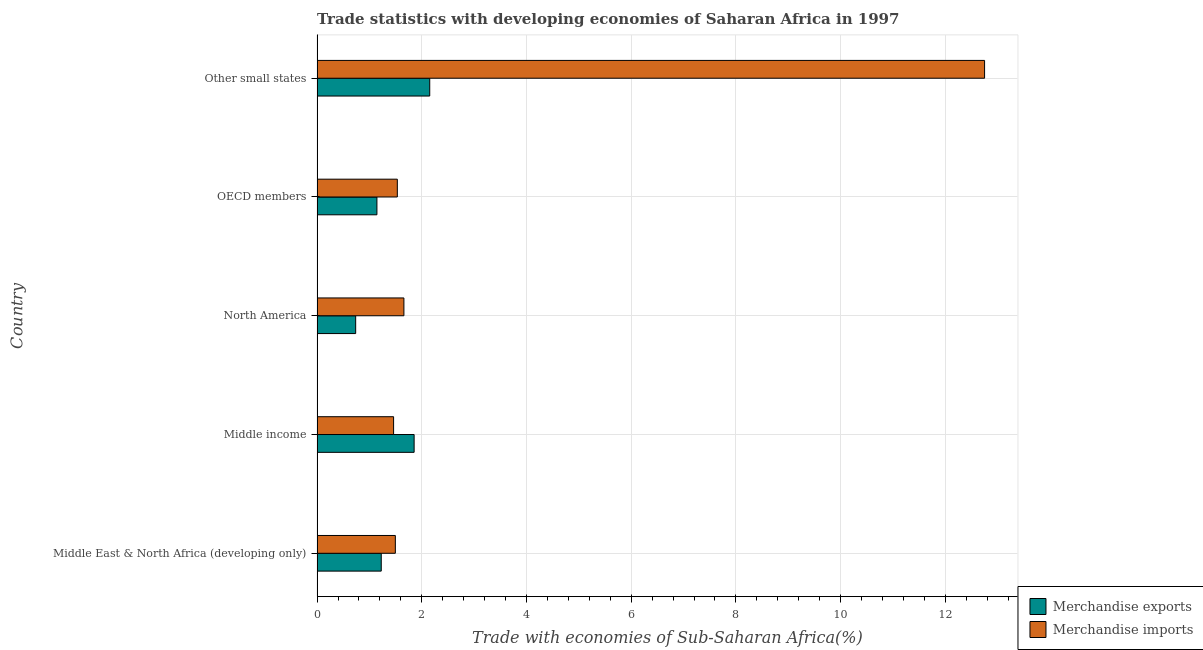How many different coloured bars are there?
Provide a short and direct response. 2. Are the number of bars per tick equal to the number of legend labels?
Your answer should be compact. Yes. Are the number of bars on each tick of the Y-axis equal?
Offer a terse response. Yes. What is the label of the 1st group of bars from the top?
Your answer should be compact. Other small states. What is the merchandise imports in North America?
Keep it short and to the point. 1.66. Across all countries, what is the maximum merchandise imports?
Your answer should be very brief. 12.75. Across all countries, what is the minimum merchandise imports?
Provide a succinct answer. 1.46. In which country was the merchandise imports maximum?
Make the answer very short. Other small states. What is the total merchandise imports in the graph?
Offer a very short reply. 18.9. What is the difference between the merchandise imports in North America and that in OECD members?
Give a very brief answer. 0.13. What is the difference between the merchandise exports in North America and the merchandise imports in Middle East & North Africa (developing only)?
Your response must be concise. -0.76. What is the average merchandise imports per country?
Offer a very short reply. 3.78. What is the difference between the merchandise exports and merchandise imports in OECD members?
Provide a short and direct response. -0.39. In how many countries, is the merchandise imports greater than 8 %?
Provide a succinct answer. 1. What is the ratio of the merchandise exports in Middle income to that in Other small states?
Your answer should be compact. 0.86. Is the merchandise exports in Middle income less than that in Other small states?
Offer a terse response. Yes. Is the difference between the merchandise exports in OECD members and Other small states greater than the difference between the merchandise imports in OECD members and Other small states?
Offer a very short reply. Yes. What is the difference between the highest and the second highest merchandise imports?
Offer a very short reply. 11.09. What is the difference between the highest and the lowest merchandise imports?
Ensure brevity in your answer.  11.29. In how many countries, is the merchandise exports greater than the average merchandise exports taken over all countries?
Your response must be concise. 2. What does the 2nd bar from the bottom in OECD members represents?
Give a very brief answer. Merchandise imports. How many bars are there?
Provide a succinct answer. 10. Are all the bars in the graph horizontal?
Provide a short and direct response. Yes. What is the difference between two consecutive major ticks on the X-axis?
Your response must be concise. 2. Does the graph contain grids?
Provide a succinct answer. Yes. Where does the legend appear in the graph?
Your response must be concise. Bottom right. How many legend labels are there?
Provide a succinct answer. 2. How are the legend labels stacked?
Your response must be concise. Vertical. What is the title of the graph?
Keep it short and to the point. Trade statistics with developing economies of Saharan Africa in 1997. What is the label or title of the X-axis?
Your answer should be compact. Trade with economies of Sub-Saharan Africa(%). What is the label or title of the Y-axis?
Offer a very short reply. Country. What is the Trade with economies of Sub-Saharan Africa(%) in Merchandise exports in Middle East & North Africa (developing only)?
Ensure brevity in your answer.  1.23. What is the Trade with economies of Sub-Saharan Africa(%) in Merchandise imports in Middle East & North Africa (developing only)?
Offer a terse response. 1.5. What is the Trade with economies of Sub-Saharan Africa(%) in Merchandise exports in Middle income?
Ensure brevity in your answer.  1.85. What is the Trade with economies of Sub-Saharan Africa(%) of Merchandise imports in Middle income?
Your answer should be very brief. 1.46. What is the Trade with economies of Sub-Saharan Africa(%) in Merchandise exports in North America?
Provide a short and direct response. 0.74. What is the Trade with economies of Sub-Saharan Africa(%) of Merchandise imports in North America?
Make the answer very short. 1.66. What is the Trade with economies of Sub-Saharan Africa(%) in Merchandise exports in OECD members?
Your answer should be very brief. 1.14. What is the Trade with economies of Sub-Saharan Africa(%) in Merchandise imports in OECD members?
Keep it short and to the point. 1.53. What is the Trade with economies of Sub-Saharan Africa(%) of Merchandise exports in Other small states?
Provide a short and direct response. 2.15. What is the Trade with economies of Sub-Saharan Africa(%) of Merchandise imports in Other small states?
Provide a short and direct response. 12.75. Across all countries, what is the maximum Trade with economies of Sub-Saharan Africa(%) in Merchandise exports?
Provide a short and direct response. 2.15. Across all countries, what is the maximum Trade with economies of Sub-Saharan Africa(%) in Merchandise imports?
Ensure brevity in your answer.  12.75. Across all countries, what is the minimum Trade with economies of Sub-Saharan Africa(%) in Merchandise exports?
Provide a succinct answer. 0.74. Across all countries, what is the minimum Trade with economies of Sub-Saharan Africa(%) in Merchandise imports?
Make the answer very short. 1.46. What is the total Trade with economies of Sub-Saharan Africa(%) in Merchandise exports in the graph?
Provide a short and direct response. 7.11. What is the total Trade with economies of Sub-Saharan Africa(%) of Merchandise imports in the graph?
Offer a terse response. 18.9. What is the difference between the Trade with economies of Sub-Saharan Africa(%) of Merchandise exports in Middle East & North Africa (developing only) and that in Middle income?
Provide a short and direct response. -0.63. What is the difference between the Trade with economies of Sub-Saharan Africa(%) of Merchandise imports in Middle East & North Africa (developing only) and that in Middle income?
Your answer should be compact. 0.03. What is the difference between the Trade with economies of Sub-Saharan Africa(%) in Merchandise exports in Middle East & North Africa (developing only) and that in North America?
Provide a succinct answer. 0.49. What is the difference between the Trade with economies of Sub-Saharan Africa(%) of Merchandise imports in Middle East & North Africa (developing only) and that in North America?
Keep it short and to the point. -0.16. What is the difference between the Trade with economies of Sub-Saharan Africa(%) in Merchandise exports in Middle East & North Africa (developing only) and that in OECD members?
Offer a very short reply. 0.08. What is the difference between the Trade with economies of Sub-Saharan Africa(%) of Merchandise imports in Middle East & North Africa (developing only) and that in OECD members?
Offer a very short reply. -0.04. What is the difference between the Trade with economies of Sub-Saharan Africa(%) of Merchandise exports in Middle East & North Africa (developing only) and that in Other small states?
Your answer should be very brief. -0.93. What is the difference between the Trade with economies of Sub-Saharan Africa(%) of Merchandise imports in Middle East & North Africa (developing only) and that in Other small states?
Give a very brief answer. -11.25. What is the difference between the Trade with economies of Sub-Saharan Africa(%) of Merchandise exports in Middle income and that in North America?
Your answer should be very brief. 1.12. What is the difference between the Trade with economies of Sub-Saharan Africa(%) of Merchandise imports in Middle income and that in North America?
Offer a terse response. -0.2. What is the difference between the Trade with economies of Sub-Saharan Africa(%) of Merchandise exports in Middle income and that in OECD members?
Make the answer very short. 0.71. What is the difference between the Trade with economies of Sub-Saharan Africa(%) in Merchandise imports in Middle income and that in OECD members?
Give a very brief answer. -0.07. What is the difference between the Trade with economies of Sub-Saharan Africa(%) of Merchandise exports in Middle income and that in Other small states?
Your response must be concise. -0.3. What is the difference between the Trade with economies of Sub-Saharan Africa(%) of Merchandise imports in Middle income and that in Other small states?
Offer a terse response. -11.29. What is the difference between the Trade with economies of Sub-Saharan Africa(%) in Merchandise exports in North America and that in OECD members?
Give a very brief answer. -0.41. What is the difference between the Trade with economies of Sub-Saharan Africa(%) in Merchandise imports in North America and that in OECD members?
Your answer should be compact. 0.13. What is the difference between the Trade with economies of Sub-Saharan Africa(%) of Merchandise exports in North America and that in Other small states?
Make the answer very short. -1.41. What is the difference between the Trade with economies of Sub-Saharan Africa(%) in Merchandise imports in North America and that in Other small states?
Provide a succinct answer. -11.09. What is the difference between the Trade with economies of Sub-Saharan Africa(%) of Merchandise exports in OECD members and that in Other small states?
Provide a succinct answer. -1.01. What is the difference between the Trade with economies of Sub-Saharan Africa(%) in Merchandise imports in OECD members and that in Other small states?
Make the answer very short. -11.22. What is the difference between the Trade with economies of Sub-Saharan Africa(%) in Merchandise exports in Middle East & North Africa (developing only) and the Trade with economies of Sub-Saharan Africa(%) in Merchandise imports in Middle income?
Your answer should be very brief. -0.24. What is the difference between the Trade with economies of Sub-Saharan Africa(%) of Merchandise exports in Middle East & North Africa (developing only) and the Trade with economies of Sub-Saharan Africa(%) of Merchandise imports in North America?
Keep it short and to the point. -0.43. What is the difference between the Trade with economies of Sub-Saharan Africa(%) in Merchandise exports in Middle East & North Africa (developing only) and the Trade with economies of Sub-Saharan Africa(%) in Merchandise imports in OECD members?
Ensure brevity in your answer.  -0.31. What is the difference between the Trade with economies of Sub-Saharan Africa(%) in Merchandise exports in Middle East & North Africa (developing only) and the Trade with economies of Sub-Saharan Africa(%) in Merchandise imports in Other small states?
Make the answer very short. -11.52. What is the difference between the Trade with economies of Sub-Saharan Africa(%) in Merchandise exports in Middle income and the Trade with economies of Sub-Saharan Africa(%) in Merchandise imports in North America?
Offer a very short reply. 0.2. What is the difference between the Trade with economies of Sub-Saharan Africa(%) of Merchandise exports in Middle income and the Trade with economies of Sub-Saharan Africa(%) of Merchandise imports in OECD members?
Give a very brief answer. 0.32. What is the difference between the Trade with economies of Sub-Saharan Africa(%) of Merchandise exports in Middle income and the Trade with economies of Sub-Saharan Africa(%) of Merchandise imports in Other small states?
Provide a short and direct response. -10.9. What is the difference between the Trade with economies of Sub-Saharan Africa(%) in Merchandise exports in North America and the Trade with economies of Sub-Saharan Africa(%) in Merchandise imports in OECD members?
Provide a succinct answer. -0.8. What is the difference between the Trade with economies of Sub-Saharan Africa(%) of Merchandise exports in North America and the Trade with economies of Sub-Saharan Africa(%) of Merchandise imports in Other small states?
Provide a short and direct response. -12.01. What is the difference between the Trade with economies of Sub-Saharan Africa(%) in Merchandise exports in OECD members and the Trade with economies of Sub-Saharan Africa(%) in Merchandise imports in Other small states?
Give a very brief answer. -11.61. What is the average Trade with economies of Sub-Saharan Africa(%) in Merchandise exports per country?
Your answer should be compact. 1.42. What is the average Trade with economies of Sub-Saharan Africa(%) of Merchandise imports per country?
Give a very brief answer. 3.78. What is the difference between the Trade with economies of Sub-Saharan Africa(%) in Merchandise exports and Trade with economies of Sub-Saharan Africa(%) in Merchandise imports in Middle East & North Africa (developing only)?
Your response must be concise. -0.27. What is the difference between the Trade with economies of Sub-Saharan Africa(%) in Merchandise exports and Trade with economies of Sub-Saharan Africa(%) in Merchandise imports in Middle income?
Keep it short and to the point. 0.39. What is the difference between the Trade with economies of Sub-Saharan Africa(%) in Merchandise exports and Trade with economies of Sub-Saharan Africa(%) in Merchandise imports in North America?
Your answer should be very brief. -0.92. What is the difference between the Trade with economies of Sub-Saharan Africa(%) of Merchandise exports and Trade with economies of Sub-Saharan Africa(%) of Merchandise imports in OECD members?
Make the answer very short. -0.39. What is the difference between the Trade with economies of Sub-Saharan Africa(%) of Merchandise exports and Trade with economies of Sub-Saharan Africa(%) of Merchandise imports in Other small states?
Your answer should be compact. -10.6. What is the ratio of the Trade with economies of Sub-Saharan Africa(%) of Merchandise exports in Middle East & North Africa (developing only) to that in Middle income?
Give a very brief answer. 0.66. What is the ratio of the Trade with economies of Sub-Saharan Africa(%) in Merchandise exports in Middle East & North Africa (developing only) to that in North America?
Keep it short and to the point. 1.66. What is the ratio of the Trade with economies of Sub-Saharan Africa(%) in Merchandise imports in Middle East & North Africa (developing only) to that in North America?
Offer a terse response. 0.9. What is the ratio of the Trade with economies of Sub-Saharan Africa(%) of Merchandise exports in Middle East & North Africa (developing only) to that in OECD members?
Your answer should be compact. 1.07. What is the ratio of the Trade with economies of Sub-Saharan Africa(%) of Merchandise imports in Middle East & North Africa (developing only) to that in OECD members?
Offer a very short reply. 0.98. What is the ratio of the Trade with economies of Sub-Saharan Africa(%) in Merchandise exports in Middle East & North Africa (developing only) to that in Other small states?
Offer a very short reply. 0.57. What is the ratio of the Trade with economies of Sub-Saharan Africa(%) in Merchandise imports in Middle East & North Africa (developing only) to that in Other small states?
Your answer should be very brief. 0.12. What is the ratio of the Trade with economies of Sub-Saharan Africa(%) in Merchandise exports in Middle income to that in North America?
Provide a short and direct response. 2.51. What is the ratio of the Trade with economies of Sub-Saharan Africa(%) in Merchandise imports in Middle income to that in North America?
Give a very brief answer. 0.88. What is the ratio of the Trade with economies of Sub-Saharan Africa(%) in Merchandise exports in Middle income to that in OECD members?
Offer a very short reply. 1.62. What is the ratio of the Trade with economies of Sub-Saharan Africa(%) in Merchandise imports in Middle income to that in OECD members?
Provide a short and direct response. 0.95. What is the ratio of the Trade with economies of Sub-Saharan Africa(%) of Merchandise exports in Middle income to that in Other small states?
Ensure brevity in your answer.  0.86. What is the ratio of the Trade with economies of Sub-Saharan Africa(%) in Merchandise imports in Middle income to that in Other small states?
Your response must be concise. 0.11. What is the ratio of the Trade with economies of Sub-Saharan Africa(%) of Merchandise exports in North America to that in OECD members?
Ensure brevity in your answer.  0.65. What is the ratio of the Trade with economies of Sub-Saharan Africa(%) in Merchandise imports in North America to that in OECD members?
Your answer should be compact. 1.08. What is the ratio of the Trade with economies of Sub-Saharan Africa(%) of Merchandise exports in North America to that in Other small states?
Your answer should be very brief. 0.34. What is the ratio of the Trade with economies of Sub-Saharan Africa(%) of Merchandise imports in North America to that in Other small states?
Give a very brief answer. 0.13. What is the ratio of the Trade with economies of Sub-Saharan Africa(%) in Merchandise exports in OECD members to that in Other small states?
Ensure brevity in your answer.  0.53. What is the ratio of the Trade with economies of Sub-Saharan Africa(%) of Merchandise imports in OECD members to that in Other small states?
Ensure brevity in your answer.  0.12. What is the difference between the highest and the second highest Trade with economies of Sub-Saharan Africa(%) of Merchandise exports?
Keep it short and to the point. 0.3. What is the difference between the highest and the second highest Trade with economies of Sub-Saharan Africa(%) of Merchandise imports?
Offer a very short reply. 11.09. What is the difference between the highest and the lowest Trade with economies of Sub-Saharan Africa(%) in Merchandise exports?
Offer a very short reply. 1.41. What is the difference between the highest and the lowest Trade with economies of Sub-Saharan Africa(%) of Merchandise imports?
Provide a short and direct response. 11.29. 